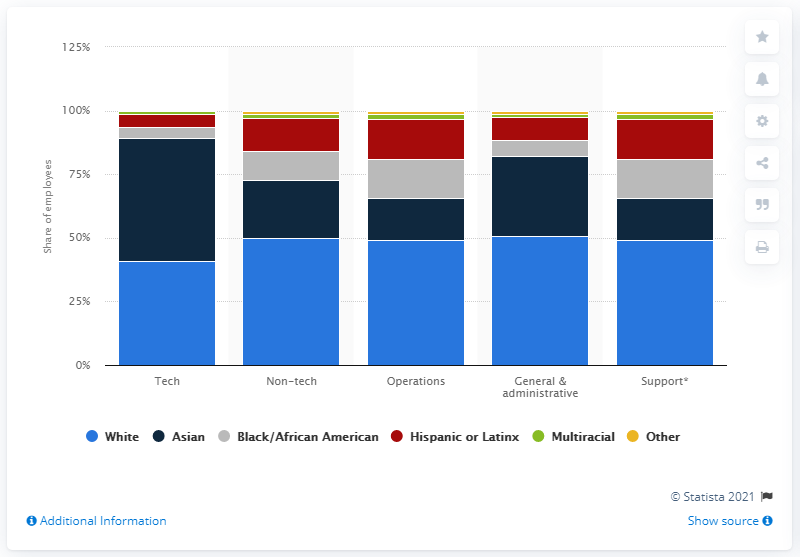Highlight a few significant elements in this photo. According to a recent report, 48.4% of Uber's tech employees belong to the ethnicity of Asian descent. 